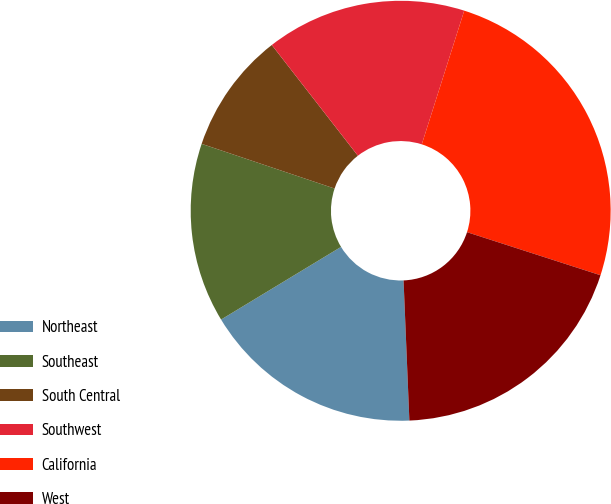Convert chart. <chart><loc_0><loc_0><loc_500><loc_500><pie_chart><fcel>Northeast<fcel>Southeast<fcel>South Central<fcel>Southwest<fcel>California<fcel>West<nl><fcel>16.99%<fcel>13.83%<fcel>9.32%<fcel>15.41%<fcel>25.07%<fcel>19.37%<nl></chart> 